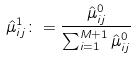<formula> <loc_0><loc_0><loc_500><loc_500>\hat { \mu } _ { i j } ^ { 1 } \colon = \frac { \hat { \mu } _ { i j } ^ { 0 } } { \sum _ { i = 1 } ^ { M + 1 } \hat { \mu } _ { i j } ^ { 0 } }</formula> 